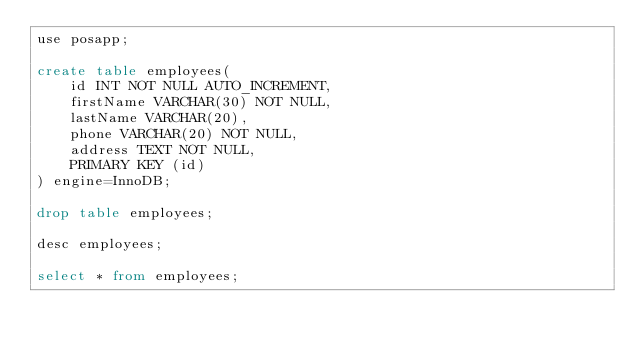Convert code to text. <code><loc_0><loc_0><loc_500><loc_500><_SQL_>use posapp;

create table employees(
	id INT NOT NULL AUTO_INCREMENT,
    firstName VARCHAR(30) NOT NULL,
    lastName VARCHAR(20),
    phone VARCHAR(20) NOT NULL,
    address TEXT NOT NULL,
    PRIMARY KEY (id)
) engine=InnoDB;

drop table employees;

desc employees;

select * from employees;</code> 